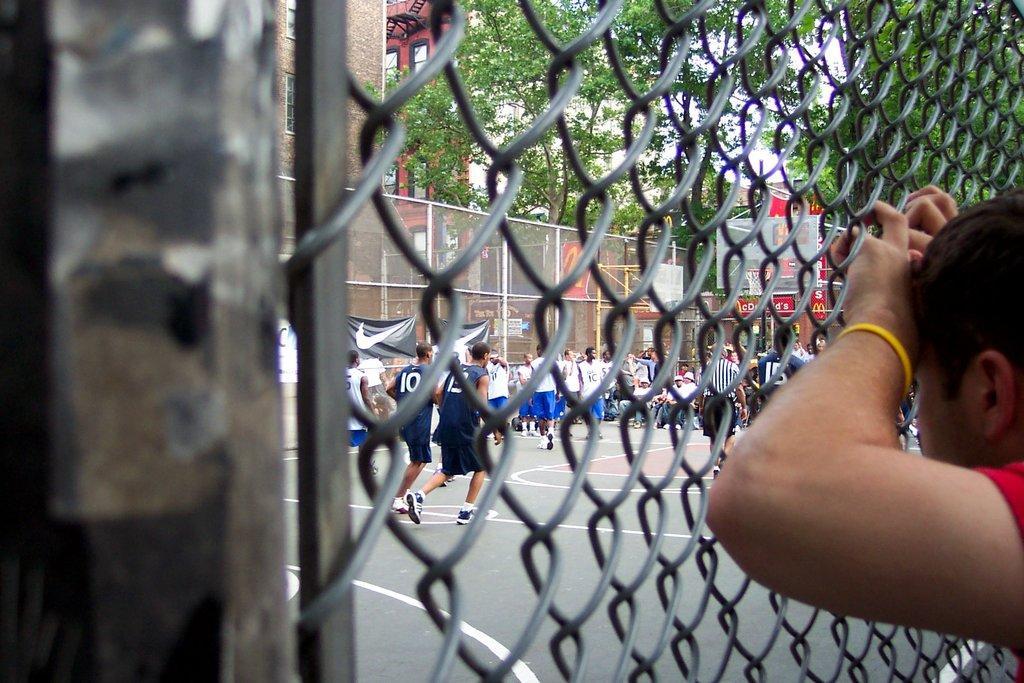Please provide a concise description of this image. In the picture I can see a group of people among them some are standing and some are running on the ground. I can also see fence, trees, buildings and some other objects. 